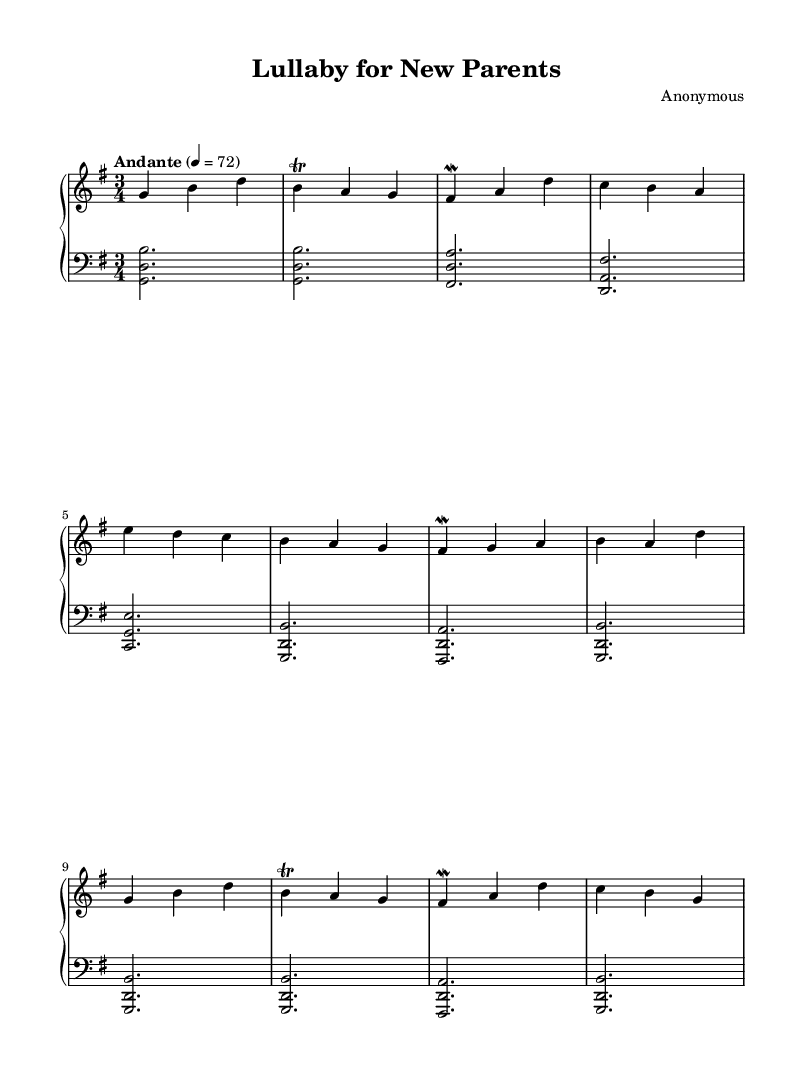What is the key signature of this music? The key signature is G major, which has one sharp, F#. Looking at the upper staff, the key signature is located at the beginning and confirms G major.
Answer: G major What is the time signature of this music? The time signature is 3/4, which indicates that there are three beats in each measure and the quarter note receives one beat. This is visible in the beginning of the sheet music.
Answer: 3/4 What tempo marking is given for the piece? The tempo marking is "Andante" with a metronome mark of 72. The tempo indication is present at the top of the score, indicating a moderate pace.
Answer: Andante 4 = 72 How many sections does the music have? The music consists of three sections: A, B, and A'. The structure is noticeable by the repetitions and variations labeled in the sheet music, with A and A' being similar but not identical.
Answer: 3 What is the predominant texture of the piece? The predominant texture of the piece is homophonic, as there is a clear melody in the upper staff supported by chordal harmonies in the lower staff. This can be inferred from the layered format of the score.
Answer: Homophonic What type of ornamentation is used in the upper staff? The ornamentation used in the upper staff includes trills and mordents, specifically on notes such as b and fis. These embellishments are indicated with specific notations in the sheet music.
Answer: Trills and mordents What is the overall mood conveyed by this piece? The overall mood conveyed by this piece is serene and reflective, as indicated by the calm tempo, gentle phrasing, and the use of soft dynamics. This can be perceived through the smooth melodic line and harmonic structure.
Answer: Serene 